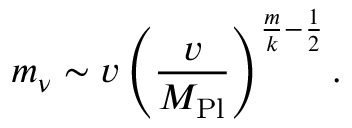Convert formula to latex. <formula><loc_0><loc_0><loc_500><loc_500>m _ { \nu } \sim v \left ( { \frac { v } { M _ { P l } } } \right ) ^ { \frac { m } { k } - \frac { 1 } { 2 } } .</formula> 